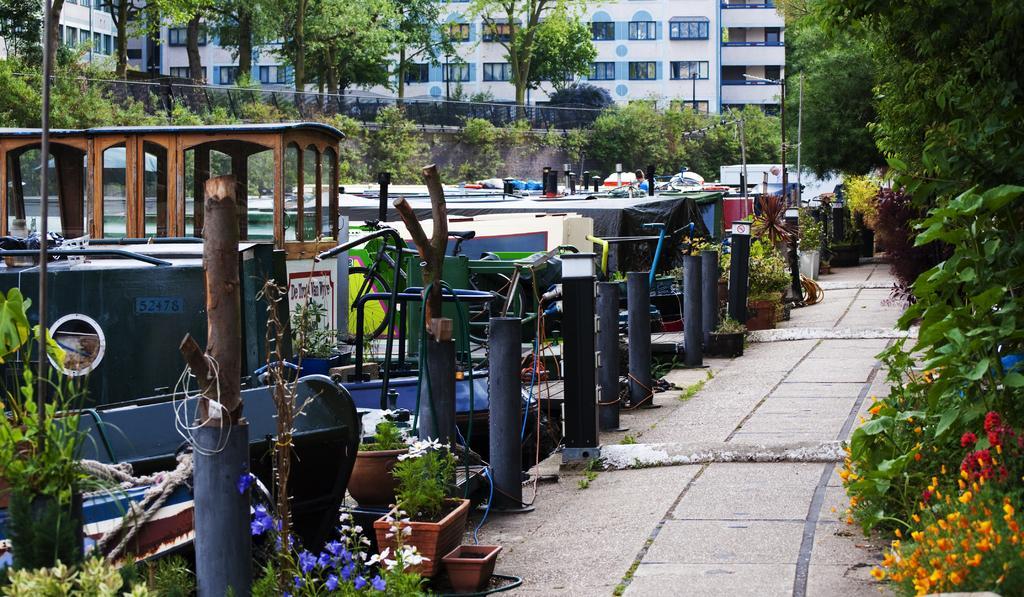In one or two sentences, can you explain what this image depicts? Here in this picture we can see number of plants present on the ground and on the left side we can see number of boats present and we can also see other plants and trees present over there and in the far we can see buildings that are fully covered with windows covered over there and we can also see lamp posts present. 